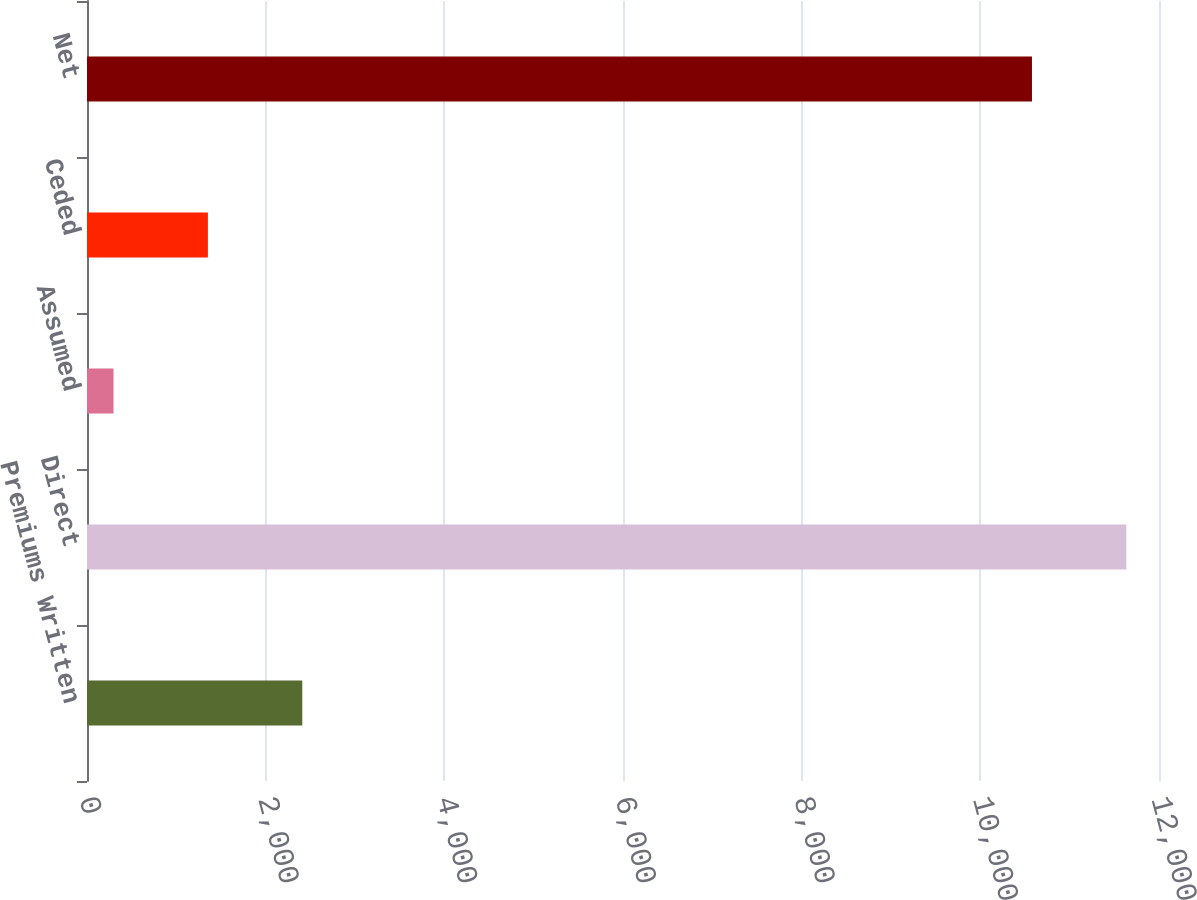Convert chart. <chart><loc_0><loc_0><loc_500><loc_500><bar_chart><fcel>Premiums Written<fcel>Direct<fcel>Assumed<fcel>Ceded<fcel>Net<nl><fcel>2409.8<fcel>11634.4<fcel>297<fcel>1353.4<fcel>10578<nl></chart> 